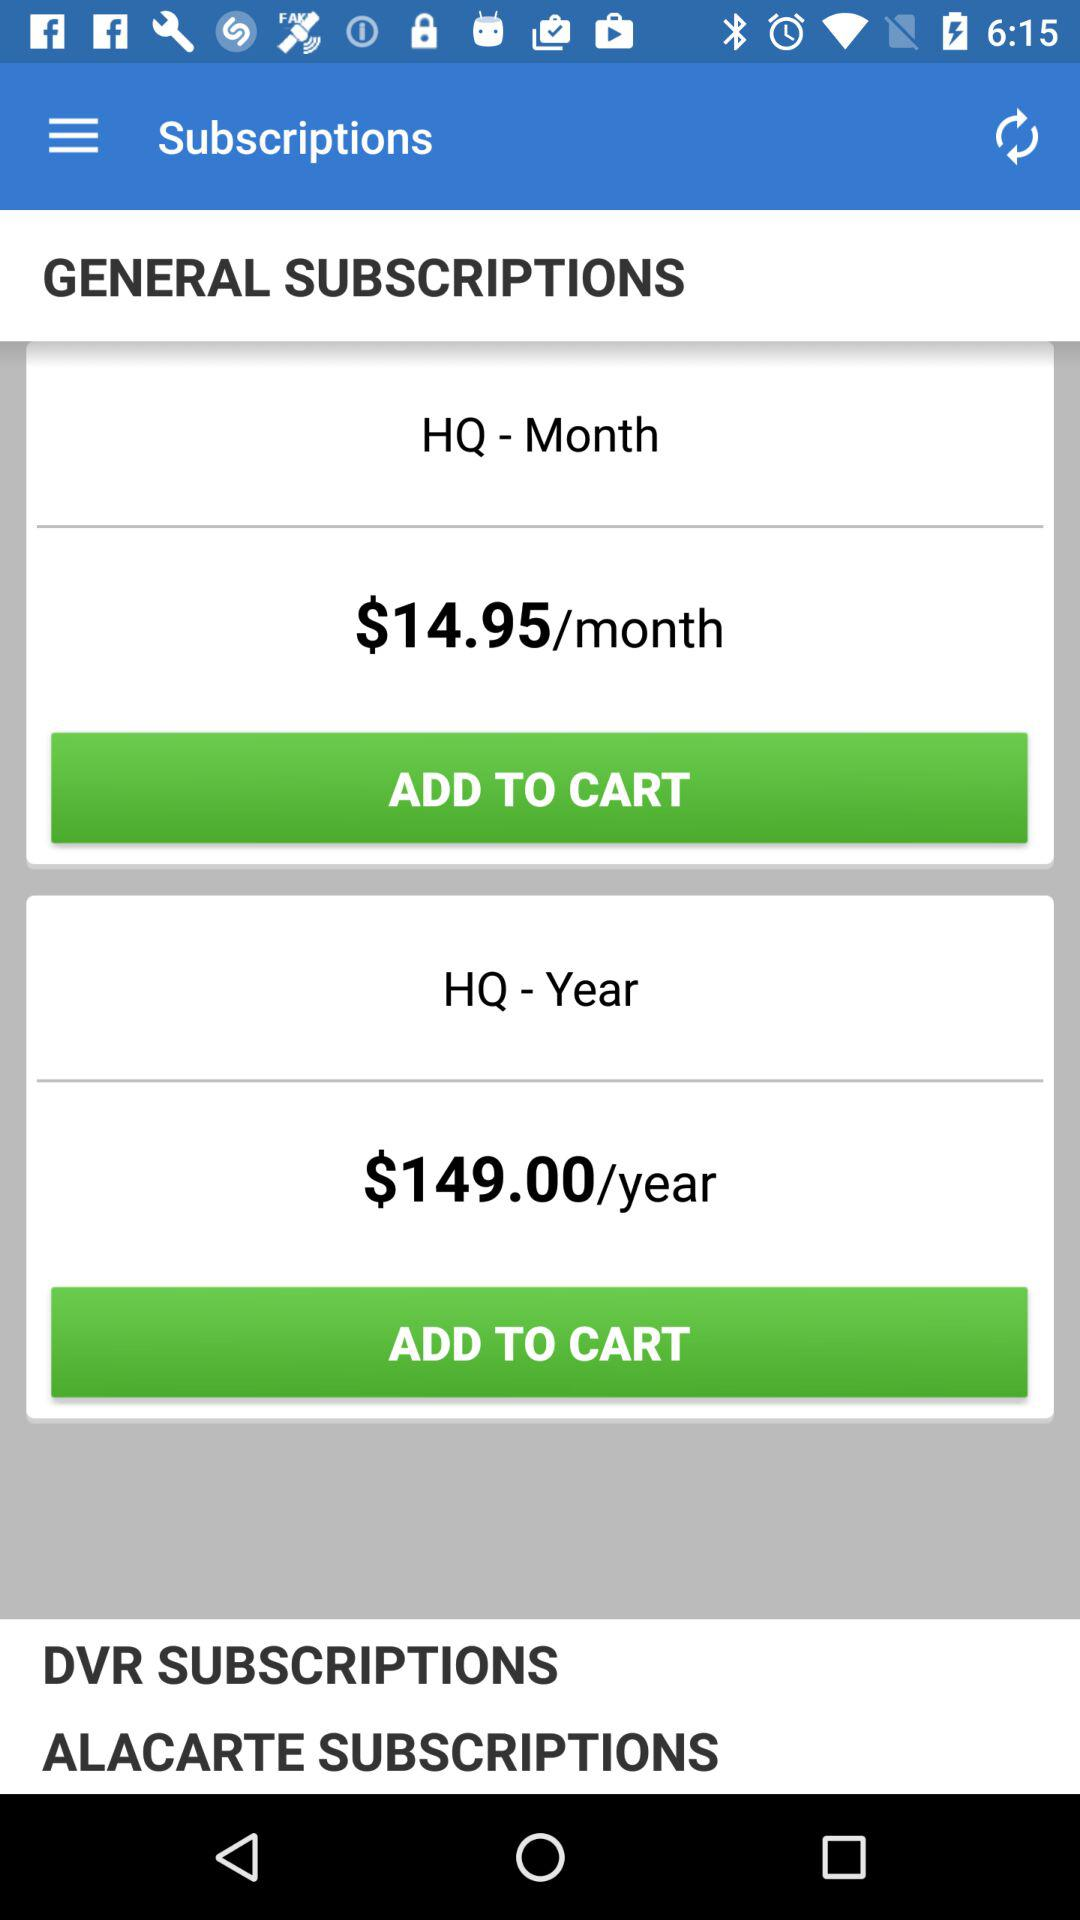How much is the monthly price of the general subscription? The monthly price of the general subscription is $14.95. 